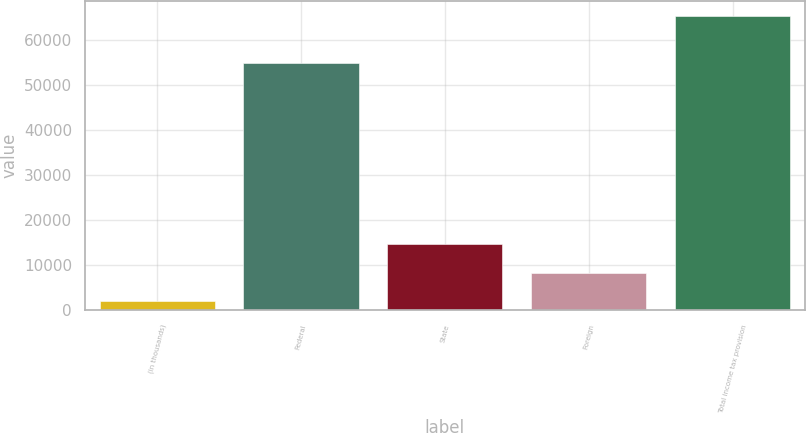<chart> <loc_0><loc_0><loc_500><loc_500><bar_chart><fcel>(in thousands)<fcel>Federal<fcel>State<fcel>Foreign<fcel>Total income tax provision<nl><fcel>2012<fcel>54815<fcel>14671.6<fcel>8341.8<fcel>65310<nl></chart> 